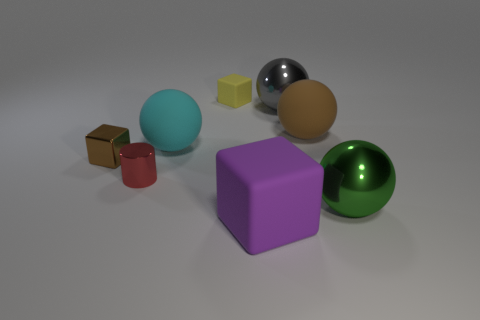Subtract all green spheres. How many spheres are left? 3 Add 2 small blocks. How many objects exist? 10 Subtract all cylinders. How many objects are left? 7 Subtract all big brown balls. Subtract all brown matte things. How many objects are left? 6 Add 8 gray balls. How many gray balls are left? 9 Add 5 big cyan shiny objects. How many big cyan shiny objects exist? 5 Subtract all cyan balls. How many balls are left? 3 Subtract 0 cyan cubes. How many objects are left? 8 Subtract all purple cylinders. Subtract all brown balls. How many cylinders are left? 1 Subtract all brown spheres. How many gray cylinders are left? 0 